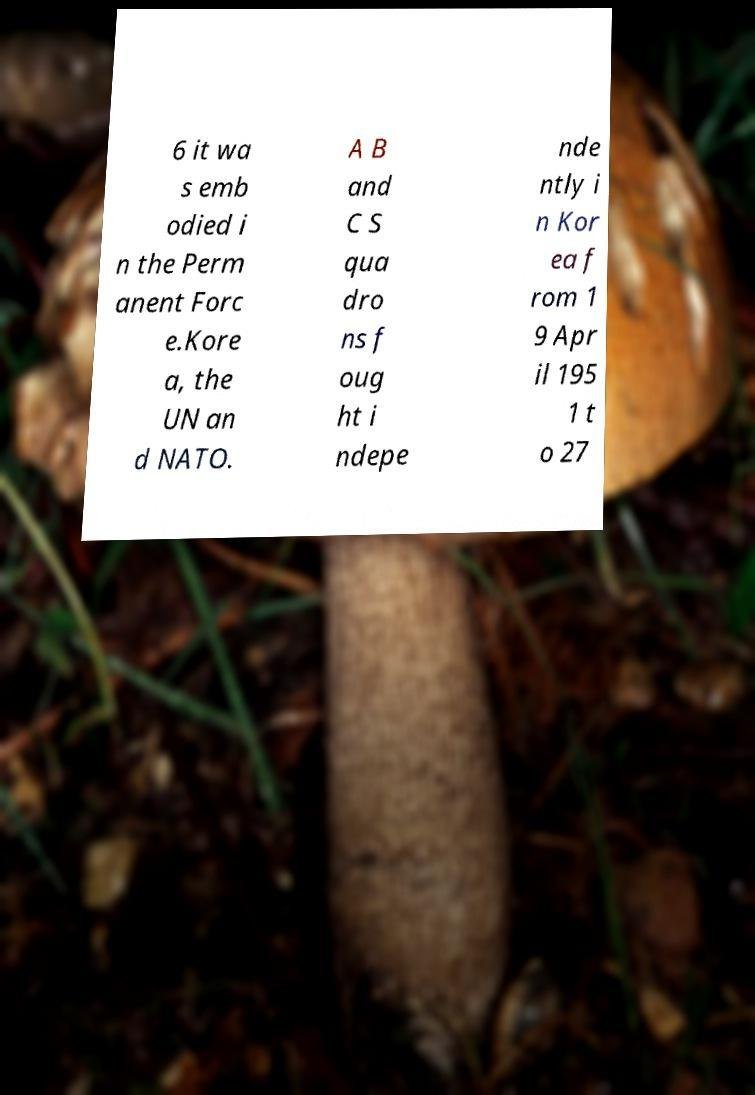I need the written content from this picture converted into text. Can you do that? 6 it wa s emb odied i n the Perm anent Forc e.Kore a, the UN an d NATO. A B and C S qua dro ns f oug ht i ndepe nde ntly i n Kor ea f rom 1 9 Apr il 195 1 t o 27 